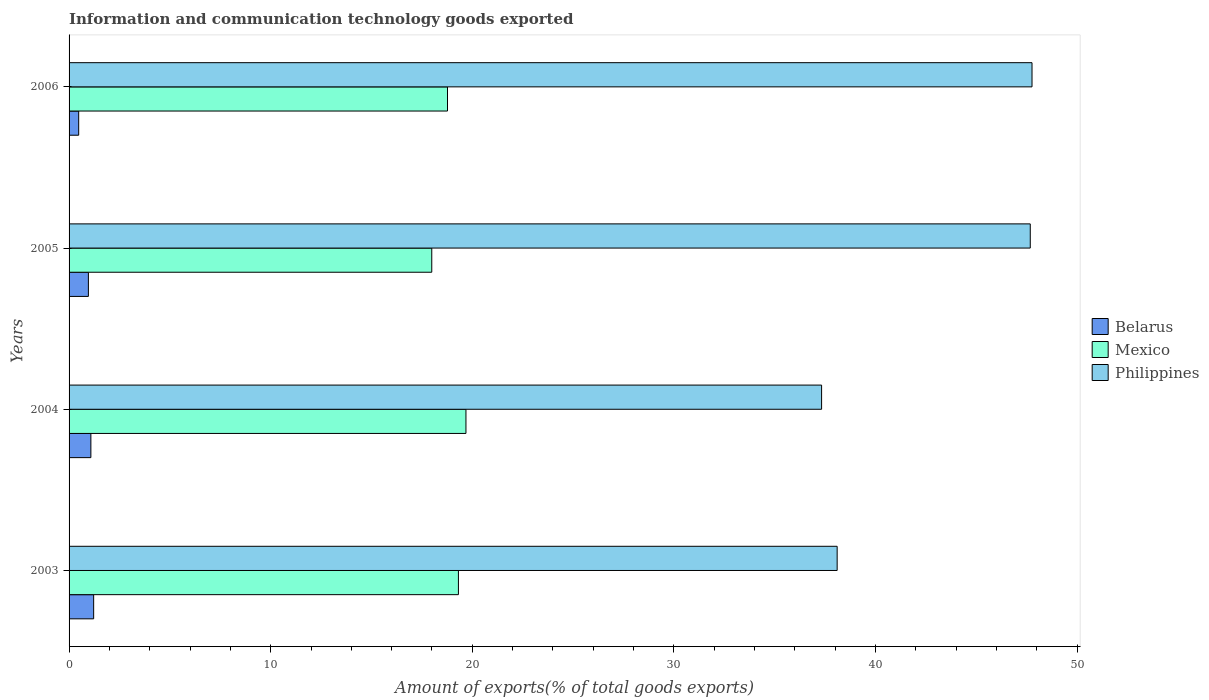How many different coloured bars are there?
Give a very brief answer. 3. How many groups of bars are there?
Your answer should be very brief. 4. How many bars are there on the 4th tick from the bottom?
Ensure brevity in your answer.  3. What is the label of the 3rd group of bars from the top?
Provide a succinct answer. 2004. In how many cases, is the number of bars for a given year not equal to the number of legend labels?
Make the answer very short. 0. What is the amount of goods exported in Mexico in 2003?
Your response must be concise. 19.31. Across all years, what is the maximum amount of goods exported in Belarus?
Keep it short and to the point. 1.22. Across all years, what is the minimum amount of goods exported in Philippines?
Make the answer very short. 37.32. In which year was the amount of goods exported in Philippines minimum?
Your answer should be compact. 2004. What is the total amount of goods exported in Belarus in the graph?
Your response must be concise. 3.74. What is the difference between the amount of goods exported in Belarus in 2004 and that in 2005?
Provide a short and direct response. 0.12. What is the difference between the amount of goods exported in Philippines in 2004 and the amount of goods exported in Mexico in 2003?
Offer a terse response. 18.01. What is the average amount of goods exported in Philippines per year?
Your response must be concise. 42.71. In the year 2003, what is the difference between the amount of goods exported in Mexico and amount of goods exported in Belarus?
Ensure brevity in your answer.  18.09. In how many years, is the amount of goods exported in Mexico greater than 12 %?
Keep it short and to the point. 4. What is the ratio of the amount of goods exported in Belarus in 2003 to that in 2004?
Provide a short and direct response. 1.13. Is the amount of goods exported in Philippines in 2003 less than that in 2005?
Provide a short and direct response. Yes. What is the difference between the highest and the second highest amount of goods exported in Philippines?
Offer a very short reply. 0.09. What is the difference between the highest and the lowest amount of goods exported in Philippines?
Your answer should be compact. 10.44. In how many years, is the amount of goods exported in Mexico greater than the average amount of goods exported in Mexico taken over all years?
Give a very brief answer. 2. Is the sum of the amount of goods exported in Belarus in 2004 and 2005 greater than the maximum amount of goods exported in Philippines across all years?
Your answer should be very brief. No. What does the 3rd bar from the bottom in 2003 represents?
Offer a terse response. Philippines. How many bars are there?
Provide a short and direct response. 12. Are all the bars in the graph horizontal?
Offer a terse response. Yes. What is the difference between two consecutive major ticks on the X-axis?
Make the answer very short. 10. How many legend labels are there?
Offer a very short reply. 3. How are the legend labels stacked?
Offer a terse response. Vertical. What is the title of the graph?
Your response must be concise. Information and communication technology goods exported. What is the label or title of the X-axis?
Keep it short and to the point. Amount of exports(% of total goods exports). What is the Amount of exports(% of total goods exports) in Belarus in 2003?
Your answer should be very brief. 1.22. What is the Amount of exports(% of total goods exports) in Mexico in 2003?
Give a very brief answer. 19.31. What is the Amount of exports(% of total goods exports) in Philippines in 2003?
Your answer should be compact. 38.1. What is the Amount of exports(% of total goods exports) of Belarus in 2004?
Give a very brief answer. 1.08. What is the Amount of exports(% of total goods exports) of Mexico in 2004?
Offer a terse response. 19.68. What is the Amount of exports(% of total goods exports) of Philippines in 2004?
Your response must be concise. 37.32. What is the Amount of exports(% of total goods exports) in Belarus in 2005?
Give a very brief answer. 0.96. What is the Amount of exports(% of total goods exports) of Mexico in 2005?
Your response must be concise. 17.99. What is the Amount of exports(% of total goods exports) in Philippines in 2005?
Your answer should be very brief. 47.67. What is the Amount of exports(% of total goods exports) in Belarus in 2006?
Your answer should be very brief. 0.48. What is the Amount of exports(% of total goods exports) in Mexico in 2006?
Provide a short and direct response. 18.77. What is the Amount of exports(% of total goods exports) in Philippines in 2006?
Provide a succinct answer. 47.76. Across all years, what is the maximum Amount of exports(% of total goods exports) in Belarus?
Your response must be concise. 1.22. Across all years, what is the maximum Amount of exports(% of total goods exports) in Mexico?
Your answer should be compact. 19.68. Across all years, what is the maximum Amount of exports(% of total goods exports) of Philippines?
Ensure brevity in your answer.  47.76. Across all years, what is the minimum Amount of exports(% of total goods exports) in Belarus?
Give a very brief answer. 0.48. Across all years, what is the minimum Amount of exports(% of total goods exports) of Mexico?
Make the answer very short. 17.99. Across all years, what is the minimum Amount of exports(% of total goods exports) in Philippines?
Offer a terse response. 37.32. What is the total Amount of exports(% of total goods exports) in Belarus in the graph?
Your answer should be compact. 3.74. What is the total Amount of exports(% of total goods exports) of Mexico in the graph?
Offer a very short reply. 75.75. What is the total Amount of exports(% of total goods exports) in Philippines in the graph?
Offer a very short reply. 170.85. What is the difference between the Amount of exports(% of total goods exports) in Belarus in 2003 and that in 2004?
Give a very brief answer. 0.14. What is the difference between the Amount of exports(% of total goods exports) of Mexico in 2003 and that in 2004?
Make the answer very short. -0.37. What is the difference between the Amount of exports(% of total goods exports) of Philippines in 2003 and that in 2004?
Offer a very short reply. 0.77. What is the difference between the Amount of exports(% of total goods exports) in Belarus in 2003 and that in 2005?
Offer a very short reply. 0.26. What is the difference between the Amount of exports(% of total goods exports) of Mexico in 2003 and that in 2005?
Offer a terse response. 1.32. What is the difference between the Amount of exports(% of total goods exports) of Philippines in 2003 and that in 2005?
Make the answer very short. -9.58. What is the difference between the Amount of exports(% of total goods exports) of Belarus in 2003 and that in 2006?
Provide a succinct answer. 0.74. What is the difference between the Amount of exports(% of total goods exports) in Mexico in 2003 and that in 2006?
Your response must be concise. 0.54. What is the difference between the Amount of exports(% of total goods exports) of Philippines in 2003 and that in 2006?
Provide a short and direct response. -9.67. What is the difference between the Amount of exports(% of total goods exports) of Belarus in 2004 and that in 2005?
Offer a terse response. 0.12. What is the difference between the Amount of exports(% of total goods exports) in Mexico in 2004 and that in 2005?
Provide a short and direct response. 1.7. What is the difference between the Amount of exports(% of total goods exports) of Philippines in 2004 and that in 2005?
Your answer should be very brief. -10.35. What is the difference between the Amount of exports(% of total goods exports) in Belarus in 2004 and that in 2006?
Provide a short and direct response. 0.6. What is the difference between the Amount of exports(% of total goods exports) in Mexico in 2004 and that in 2006?
Keep it short and to the point. 0.92. What is the difference between the Amount of exports(% of total goods exports) in Philippines in 2004 and that in 2006?
Make the answer very short. -10.44. What is the difference between the Amount of exports(% of total goods exports) in Belarus in 2005 and that in 2006?
Offer a terse response. 0.48. What is the difference between the Amount of exports(% of total goods exports) in Mexico in 2005 and that in 2006?
Your answer should be compact. -0.78. What is the difference between the Amount of exports(% of total goods exports) in Philippines in 2005 and that in 2006?
Make the answer very short. -0.09. What is the difference between the Amount of exports(% of total goods exports) of Belarus in 2003 and the Amount of exports(% of total goods exports) of Mexico in 2004?
Your answer should be very brief. -18.46. What is the difference between the Amount of exports(% of total goods exports) in Belarus in 2003 and the Amount of exports(% of total goods exports) in Philippines in 2004?
Your response must be concise. -36.1. What is the difference between the Amount of exports(% of total goods exports) in Mexico in 2003 and the Amount of exports(% of total goods exports) in Philippines in 2004?
Offer a very short reply. -18.01. What is the difference between the Amount of exports(% of total goods exports) in Belarus in 2003 and the Amount of exports(% of total goods exports) in Mexico in 2005?
Make the answer very short. -16.77. What is the difference between the Amount of exports(% of total goods exports) in Belarus in 2003 and the Amount of exports(% of total goods exports) in Philippines in 2005?
Offer a very short reply. -46.45. What is the difference between the Amount of exports(% of total goods exports) in Mexico in 2003 and the Amount of exports(% of total goods exports) in Philippines in 2005?
Your response must be concise. -28.36. What is the difference between the Amount of exports(% of total goods exports) of Belarus in 2003 and the Amount of exports(% of total goods exports) of Mexico in 2006?
Ensure brevity in your answer.  -17.55. What is the difference between the Amount of exports(% of total goods exports) of Belarus in 2003 and the Amount of exports(% of total goods exports) of Philippines in 2006?
Your answer should be very brief. -46.54. What is the difference between the Amount of exports(% of total goods exports) in Mexico in 2003 and the Amount of exports(% of total goods exports) in Philippines in 2006?
Your answer should be very brief. -28.45. What is the difference between the Amount of exports(% of total goods exports) in Belarus in 2004 and the Amount of exports(% of total goods exports) in Mexico in 2005?
Provide a short and direct response. -16.91. What is the difference between the Amount of exports(% of total goods exports) of Belarus in 2004 and the Amount of exports(% of total goods exports) of Philippines in 2005?
Ensure brevity in your answer.  -46.59. What is the difference between the Amount of exports(% of total goods exports) in Mexico in 2004 and the Amount of exports(% of total goods exports) in Philippines in 2005?
Ensure brevity in your answer.  -27.99. What is the difference between the Amount of exports(% of total goods exports) in Belarus in 2004 and the Amount of exports(% of total goods exports) in Mexico in 2006?
Provide a short and direct response. -17.69. What is the difference between the Amount of exports(% of total goods exports) of Belarus in 2004 and the Amount of exports(% of total goods exports) of Philippines in 2006?
Make the answer very short. -46.68. What is the difference between the Amount of exports(% of total goods exports) of Mexico in 2004 and the Amount of exports(% of total goods exports) of Philippines in 2006?
Make the answer very short. -28.08. What is the difference between the Amount of exports(% of total goods exports) of Belarus in 2005 and the Amount of exports(% of total goods exports) of Mexico in 2006?
Provide a succinct answer. -17.81. What is the difference between the Amount of exports(% of total goods exports) of Belarus in 2005 and the Amount of exports(% of total goods exports) of Philippines in 2006?
Provide a succinct answer. -46.8. What is the difference between the Amount of exports(% of total goods exports) in Mexico in 2005 and the Amount of exports(% of total goods exports) in Philippines in 2006?
Make the answer very short. -29.77. What is the average Amount of exports(% of total goods exports) in Belarus per year?
Provide a succinct answer. 0.93. What is the average Amount of exports(% of total goods exports) in Mexico per year?
Give a very brief answer. 18.94. What is the average Amount of exports(% of total goods exports) in Philippines per year?
Give a very brief answer. 42.71. In the year 2003, what is the difference between the Amount of exports(% of total goods exports) of Belarus and Amount of exports(% of total goods exports) of Mexico?
Your answer should be very brief. -18.09. In the year 2003, what is the difference between the Amount of exports(% of total goods exports) of Belarus and Amount of exports(% of total goods exports) of Philippines?
Offer a terse response. -36.88. In the year 2003, what is the difference between the Amount of exports(% of total goods exports) in Mexico and Amount of exports(% of total goods exports) in Philippines?
Provide a short and direct response. -18.78. In the year 2004, what is the difference between the Amount of exports(% of total goods exports) in Belarus and Amount of exports(% of total goods exports) in Mexico?
Provide a succinct answer. -18.6. In the year 2004, what is the difference between the Amount of exports(% of total goods exports) in Belarus and Amount of exports(% of total goods exports) in Philippines?
Offer a very short reply. -36.24. In the year 2004, what is the difference between the Amount of exports(% of total goods exports) of Mexico and Amount of exports(% of total goods exports) of Philippines?
Keep it short and to the point. -17.64. In the year 2005, what is the difference between the Amount of exports(% of total goods exports) of Belarus and Amount of exports(% of total goods exports) of Mexico?
Your answer should be very brief. -17.03. In the year 2005, what is the difference between the Amount of exports(% of total goods exports) in Belarus and Amount of exports(% of total goods exports) in Philippines?
Offer a very short reply. -46.72. In the year 2005, what is the difference between the Amount of exports(% of total goods exports) in Mexico and Amount of exports(% of total goods exports) in Philippines?
Ensure brevity in your answer.  -29.69. In the year 2006, what is the difference between the Amount of exports(% of total goods exports) of Belarus and Amount of exports(% of total goods exports) of Mexico?
Provide a short and direct response. -18.29. In the year 2006, what is the difference between the Amount of exports(% of total goods exports) in Belarus and Amount of exports(% of total goods exports) in Philippines?
Offer a terse response. -47.28. In the year 2006, what is the difference between the Amount of exports(% of total goods exports) of Mexico and Amount of exports(% of total goods exports) of Philippines?
Your answer should be compact. -28.99. What is the ratio of the Amount of exports(% of total goods exports) of Belarus in 2003 to that in 2004?
Provide a short and direct response. 1.13. What is the ratio of the Amount of exports(% of total goods exports) in Philippines in 2003 to that in 2004?
Offer a terse response. 1.02. What is the ratio of the Amount of exports(% of total goods exports) of Belarus in 2003 to that in 2005?
Your answer should be very brief. 1.27. What is the ratio of the Amount of exports(% of total goods exports) in Mexico in 2003 to that in 2005?
Make the answer very short. 1.07. What is the ratio of the Amount of exports(% of total goods exports) of Philippines in 2003 to that in 2005?
Your answer should be very brief. 0.8. What is the ratio of the Amount of exports(% of total goods exports) in Belarus in 2003 to that in 2006?
Make the answer very short. 2.56. What is the ratio of the Amount of exports(% of total goods exports) of Mexico in 2003 to that in 2006?
Offer a terse response. 1.03. What is the ratio of the Amount of exports(% of total goods exports) in Philippines in 2003 to that in 2006?
Give a very brief answer. 0.8. What is the ratio of the Amount of exports(% of total goods exports) of Belarus in 2004 to that in 2005?
Your answer should be very brief. 1.13. What is the ratio of the Amount of exports(% of total goods exports) in Mexico in 2004 to that in 2005?
Provide a short and direct response. 1.09. What is the ratio of the Amount of exports(% of total goods exports) in Philippines in 2004 to that in 2005?
Your answer should be compact. 0.78. What is the ratio of the Amount of exports(% of total goods exports) in Belarus in 2004 to that in 2006?
Keep it short and to the point. 2.27. What is the ratio of the Amount of exports(% of total goods exports) in Mexico in 2004 to that in 2006?
Offer a very short reply. 1.05. What is the ratio of the Amount of exports(% of total goods exports) of Philippines in 2004 to that in 2006?
Your answer should be very brief. 0.78. What is the ratio of the Amount of exports(% of total goods exports) in Belarus in 2005 to that in 2006?
Offer a terse response. 2.01. What is the ratio of the Amount of exports(% of total goods exports) of Mexico in 2005 to that in 2006?
Give a very brief answer. 0.96. What is the difference between the highest and the second highest Amount of exports(% of total goods exports) of Belarus?
Your answer should be very brief. 0.14. What is the difference between the highest and the second highest Amount of exports(% of total goods exports) of Mexico?
Your response must be concise. 0.37. What is the difference between the highest and the second highest Amount of exports(% of total goods exports) of Philippines?
Ensure brevity in your answer.  0.09. What is the difference between the highest and the lowest Amount of exports(% of total goods exports) in Belarus?
Make the answer very short. 0.74. What is the difference between the highest and the lowest Amount of exports(% of total goods exports) in Mexico?
Provide a succinct answer. 1.7. What is the difference between the highest and the lowest Amount of exports(% of total goods exports) of Philippines?
Provide a short and direct response. 10.44. 